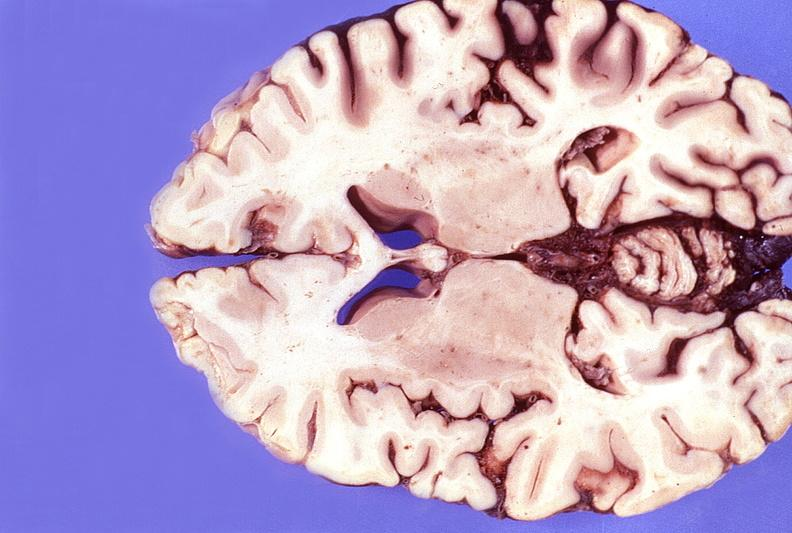s penis present?
Answer the question using a single word or phrase. No 